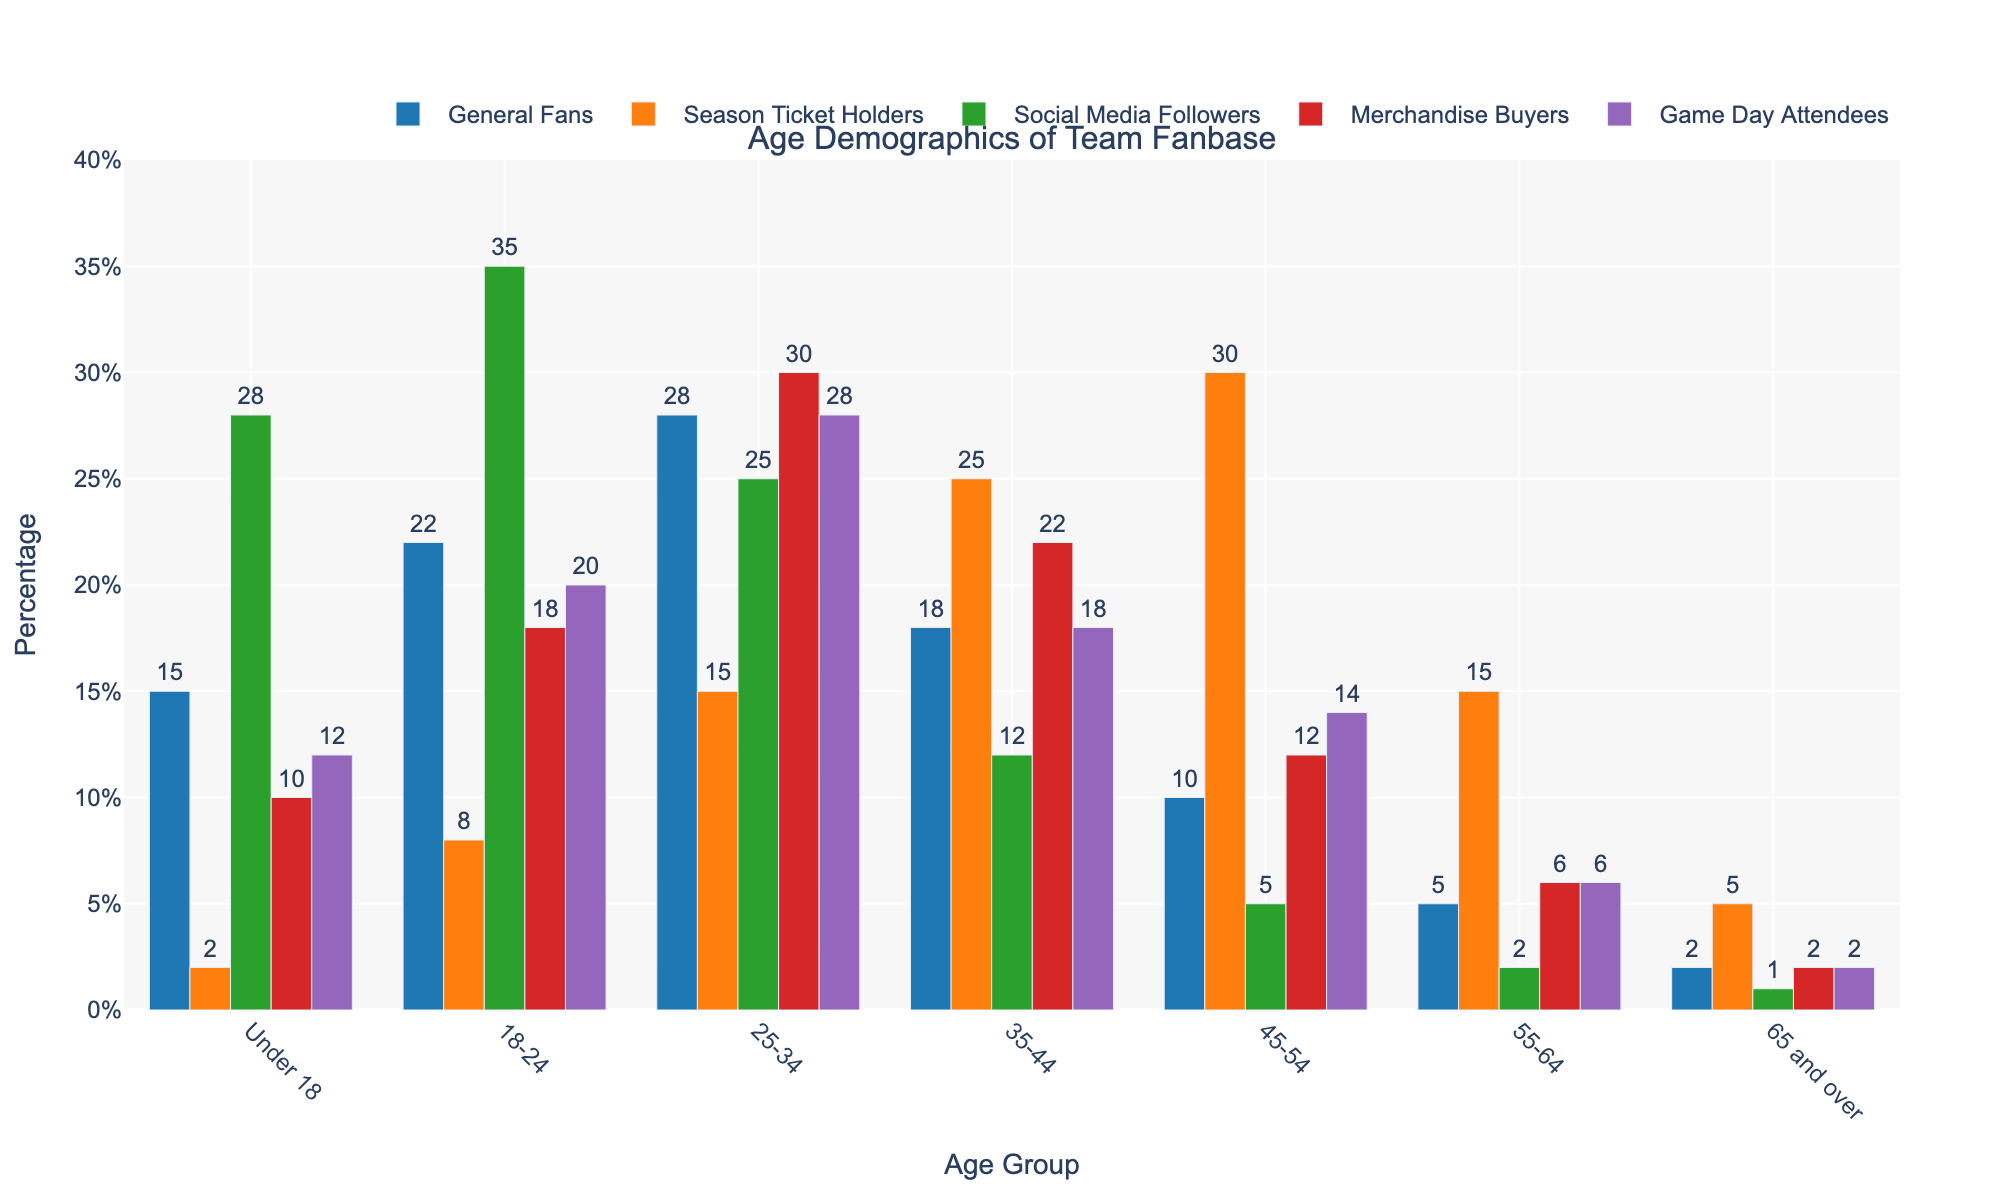What's the most popular age group among Social Media Followers? By examining the heights of the bars for Social Media Followers across different age groups, the bar for the 18-24 age group is the highest.
Answer: 18-24 Which age group has the most significant number of General Fans? Looking at the bar heights for General Fans, the tallest bar corresponds to the 25-34 age group.
Answer: 25-34 What is the difference in the number of Season Ticket Holders between the 45-54 and the 55-64 age groups? The bar for Season Ticket Holders in the 45-54 age group is at 30, and for the 55-64 age group is at 15. Subtracting these, 30 - 15 = 15.
Answer: 15 In terms of Merchandise Buyers, which two age groups have the smallest tallies combined? By visually comparing the height of the bars for Merchandise Buyers, the smallest tallies are in the 65 and over (2) and the 55-64 (6) age groups. Their combined total is 2 + 6 = 8.
Answer: 65 and over and 55-64 How does the number of Game Day Attendees in the 35-44 age group compare to those in the 18-24 age group? Looking at the bar heights, the 35-44 age group has 18 Game Day Attendees, and the 18-24 age group has 20. The 18-24 age group has a higher number of Game Day Attendees by 2.
Answer: 18-24 has 2 more What’s the total number of Season Ticket Holders aged 18-44? Summing the counts of Season Ticket Holders for the 18-24, 25-34, and 35-44 age groups: 8 (18-24) + 15 (25-34) + 25 (35-44) = 48.
Answer: 48 What's the combined percentage of Social Media Followers for the Under 18 and 65 and over age groups? Adding the counts of Social Media Followers in these age groups: 28 (Under 18) + 1 (65 and over) = 29.
Answer: 29 Which age group has the fewest Merchandise Buyers? The bar for Merchandise Buyers is the shortest for the 65 and over age group, showing that it has the fewest buyers.
Answer: 65 and over 